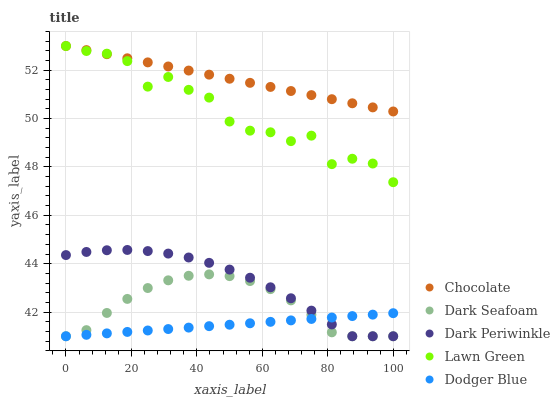Does Dodger Blue have the minimum area under the curve?
Answer yes or no. Yes. Does Chocolate have the maximum area under the curve?
Answer yes or no. Yes. Does Dark Seafoam have the minimum area under the curve?
Answer yes or no. No. Does Dark Seafoam have the maximum area under the curve?
Answer yes or no. No. Is Chocolate the smoothest?
Answer yes or no. Yes. Is Lawn Green the roughest?
Answer yes or no. Yes. Is Dark Seafoam the smoothest?
Answer yes or no. No. Is Dark Seafoam the roughest?
Answer yes or no. No. Does Dark Seafoam have the lowest value?
Answer yes or no. Yes. Does Chocolate have the lowest value?
Answer yes or no. No. Does Chocolate have the highest value?
Answer yes or no. Yes. Does Dark Seafoam have the highest value?
Answer yes or no. No. Is Dodger Blue less than Lawn Green?
Answer yes or no. Yes. Is Lawn Green greater than Dark Seafoam?
Answer yes or no. Yes. Does Lawn Green intersect Chocolate?
Answer yes or no. Yes. Is Lawn Green less than Chocolate?
Answer yes or no. No. Is Lawn Green greater than Chocolate?
Answer yes or no. No. Does Dodger Blue intersect Lawn Green?
Answer yes or no. No. 